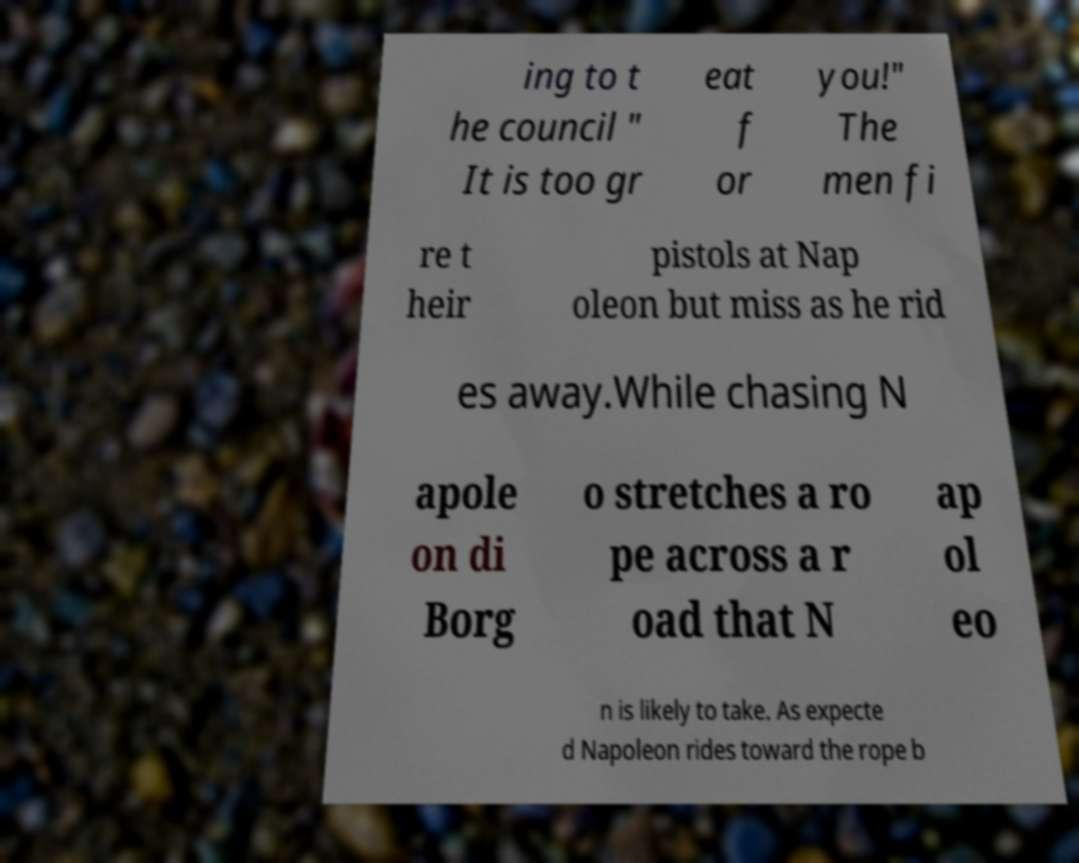Please identify and transcribe the text found in this image. ing to t he council " It is too gr eat f or you!" The men fi re t heir pistols at Nap oleon but miss as he rid es away.While chasing N apole on di Borg o stretches a ro pe across a r oad that N ap ol eo n is likely to take. As expecte d Napoleon rides toward the rope b 